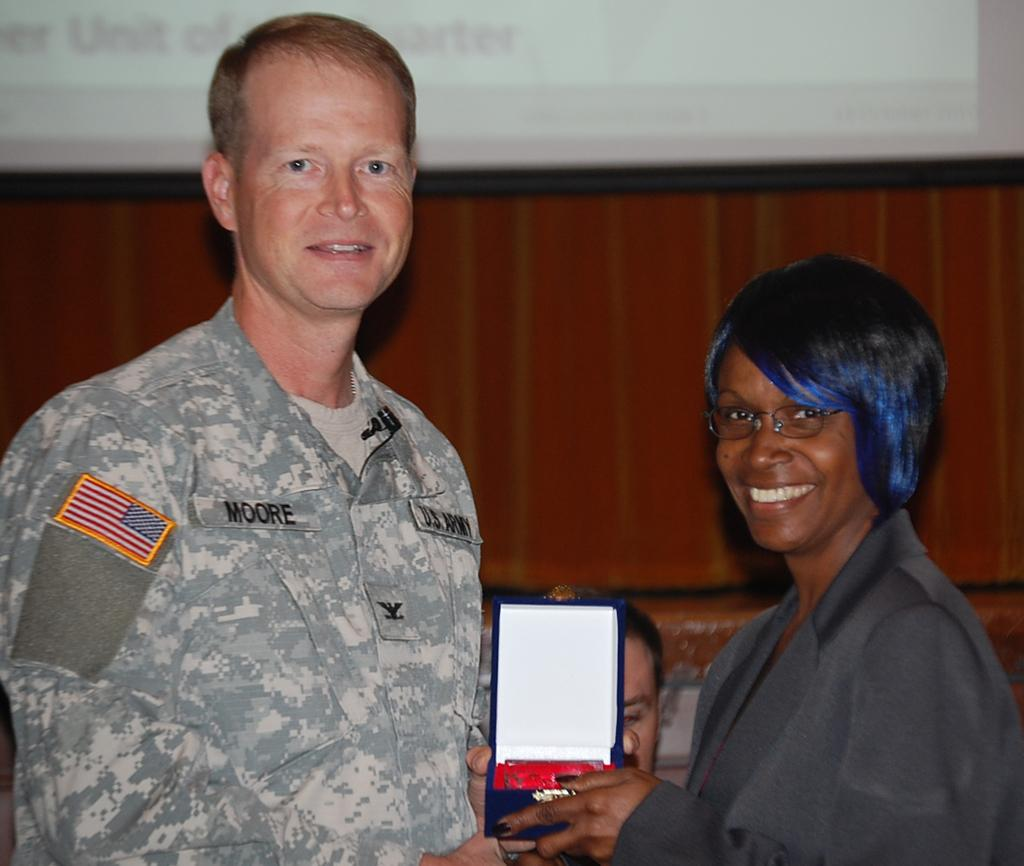How many people are in the image? There are people in the image, but the exact number is not specified. What is the lady doing in the image? The lady is giving an object to a person in the image. What type of material is used for the wall in the image? There is a wooden wall in the image. What can be seen on the wall in the image? The presence of a screen is mentioned in the image. Can you see a cat playing with water near the mailbox in the image? There is no mention of a cat, water, or mailbox in the image, so we cannot confirm their presence. 